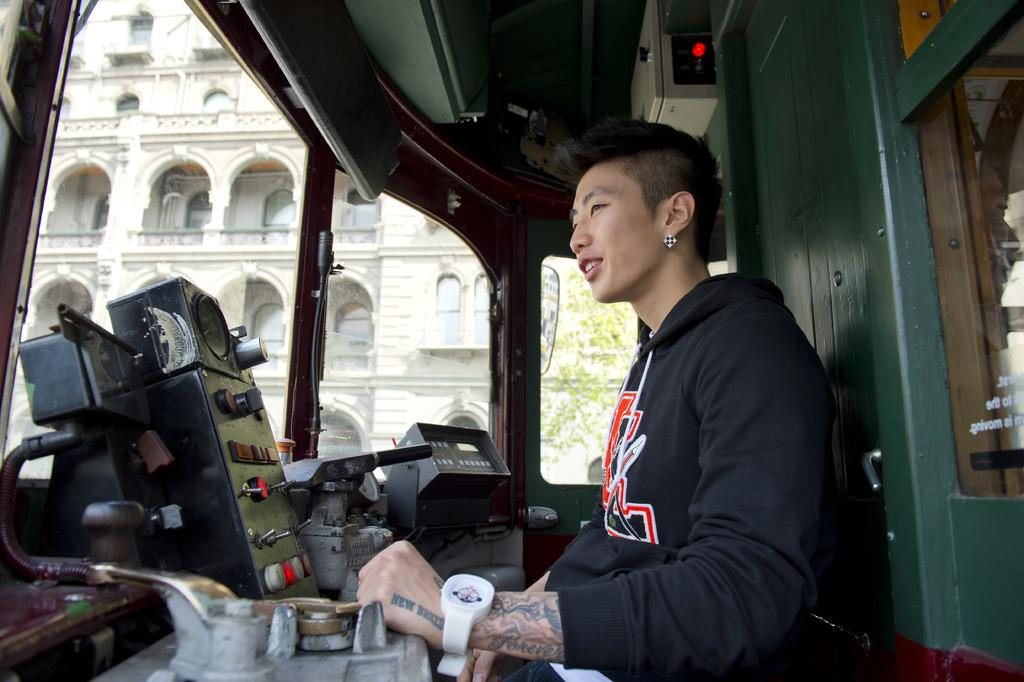What type of structure is visible in the image? There is a building in the image. What natural element is present in the image? There is a tree in the image. What is the person in the image doing? The person is sitting in a vehicle. What type of machine is present in the image? There is a current machine in the image. What electrical component is visible in the image? There is a meter box in the image. Can you describe any other objects in the image? There are additional objects in the image, but their specific details are not mentioned in the provided facts. What type of lead is being exchanged between the person and the tree in the image? There is no lead or exchange between the person and the tree in the image; the person is sitting in a vehicle, and the tree is a separate element in the image. What kind of bubble can be seen surrounding the building in the image? There is no bubble present in the image; it features a building, a tree, a person in a vehicle, a current machine, a meter box, and additional objects. 